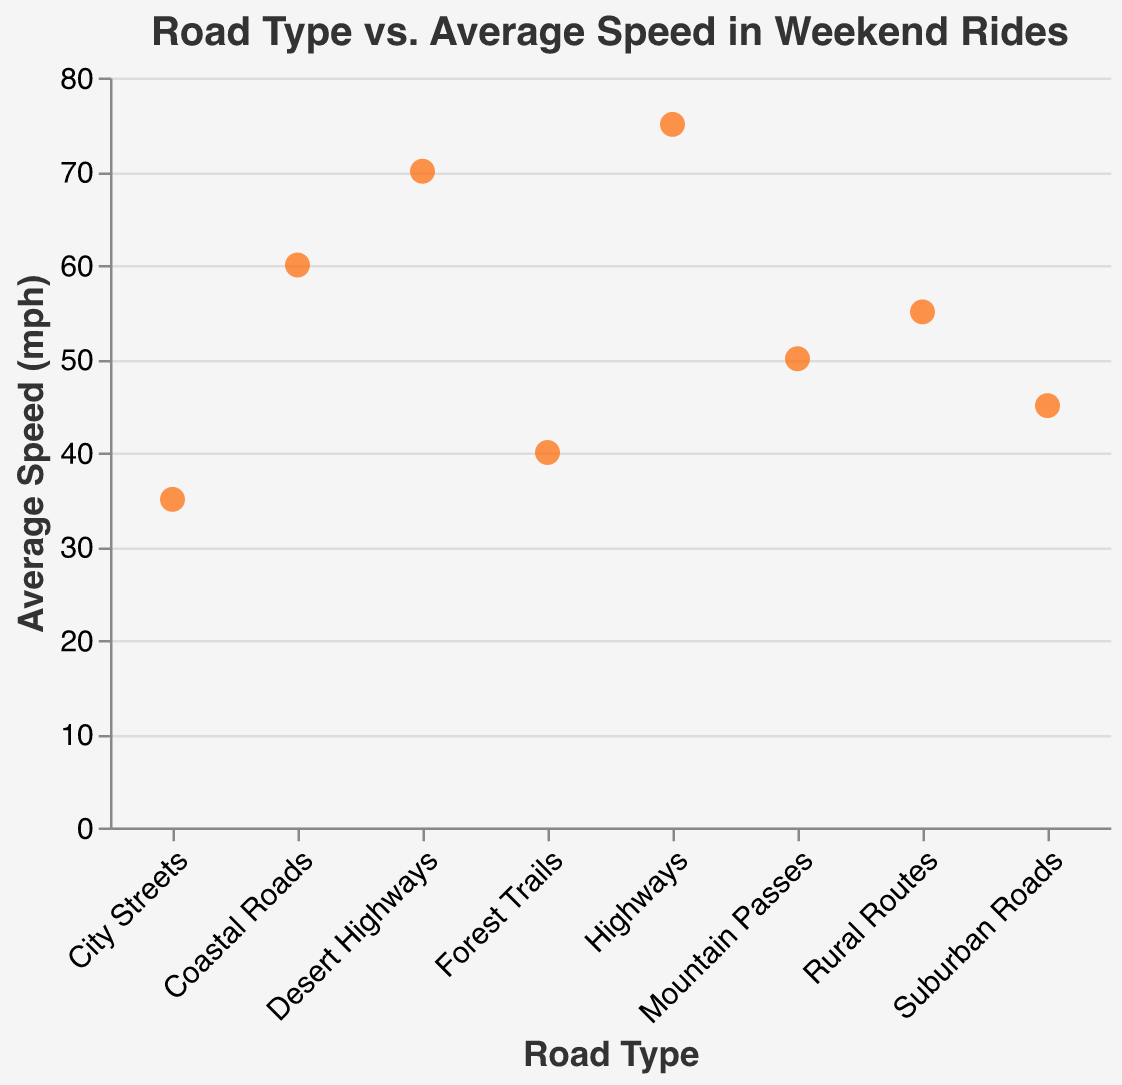What is the title of the plot? The title is usually located at the top of the plot. The title helps to give the viewer an idea of what the plot represents.
Answer: Road Type vs. Average Speed in Weekend Rides How many different road types are shown in the plot? Count the number of unique data points along the x-axis that denote different road types.
Answer: 8 Which road type has the highest average speed? Look for the data point on the plot with the highest y-value, which represents the 'Average Speed (mph)', and note its corresponding x-value.
Answer: Highways What is the average speed for Coastal Roads? Identify the data point labeled 'Coastal Roads' on the x-axis and read off its corresponding y-value, which indicates the 'Average Speed (mph)'.
Answer: 60 Which road type has an average speed of 55 mph? Locate the data point that corresponds to the y-value of 55 mph and note its associated road type on the x-axis.
Answer: Rural Routes What is the difference in average speed between Desert Highways and City Streets? Find the average speed for both 'Desert Highways' and 'City Streets', then subtract the latter from the former: 70 mph - 35 mph.
Answer: 35 mph Which road type has the lowest average speed? Identify the data point with the smallest y-value, which represents the 'Average Speed (mph)', and note its corresponding road type.
Answer: City Streets What is the combined average speed of Forest Trails and Suburban Roads? Add the average speeds of 'Forest Trails' and 'Suburban Roads' together: 40 mph + 45 mph.
Answer: 85 mph How do Coastal Roads and Mountain Passes compare in terms of average speed? Look at the average speeds of both 'Coastal Roads' and 'Mountain Passes' and compare their y-values. Coastal Roads have 60 mph, and Mountain Passes have 50 mph.
Answer: Coastal Roads are faster Which data point appears closest to the middle of the y-axis range set from 0 to 80 mph? The midpoint of 0 to 80 is 40 mph. Check which data point has an average speed closest to this value.
Answer: Forest Trails (40 mph) 